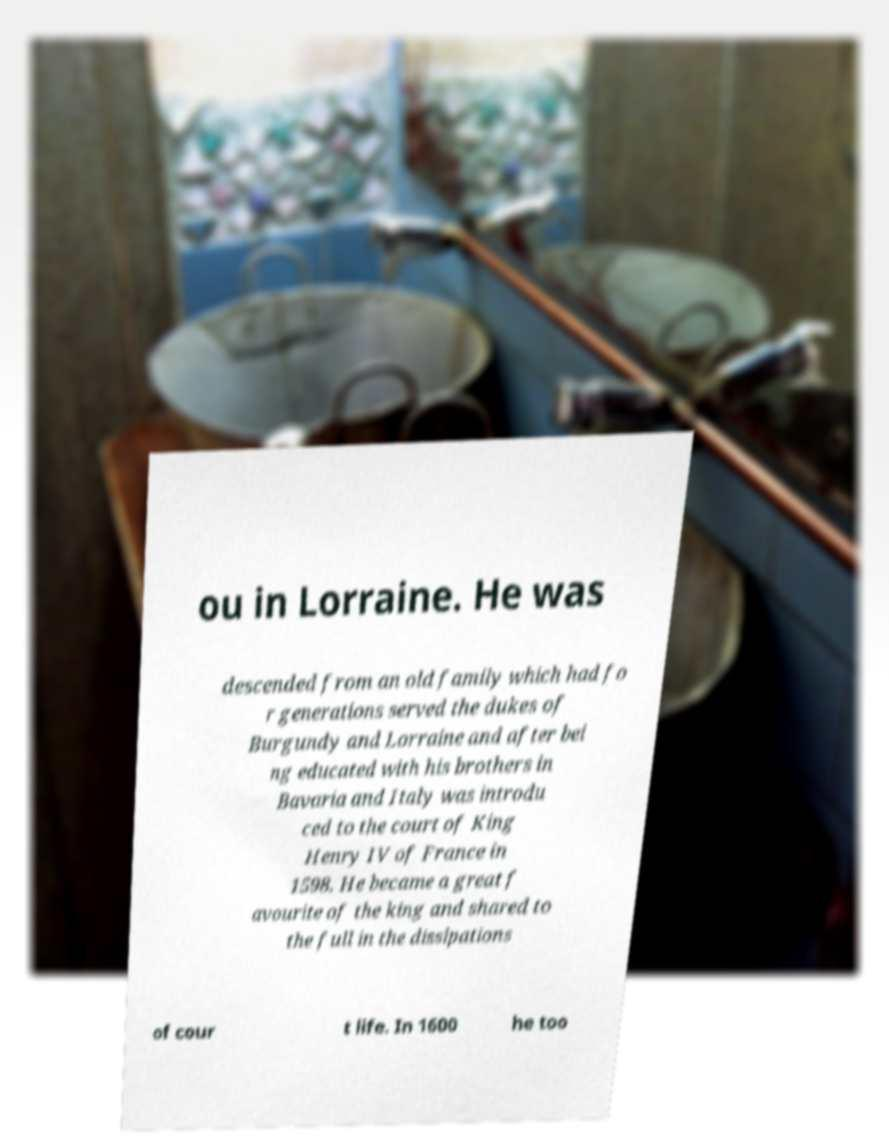Can you accurately transcribe the text from the provided image for me? ou in Lorraine. He was descended from an old family which had fo r generations served the dukes of Burgundy and Lorraine and after bei ng educated with his brothers in Bavaria and Italy was introdu ced to the court of King Henry IV of France in 1598. He became a great f avourite of the king and shared to the full in the dissipations of cour t life. In 1600 he too 